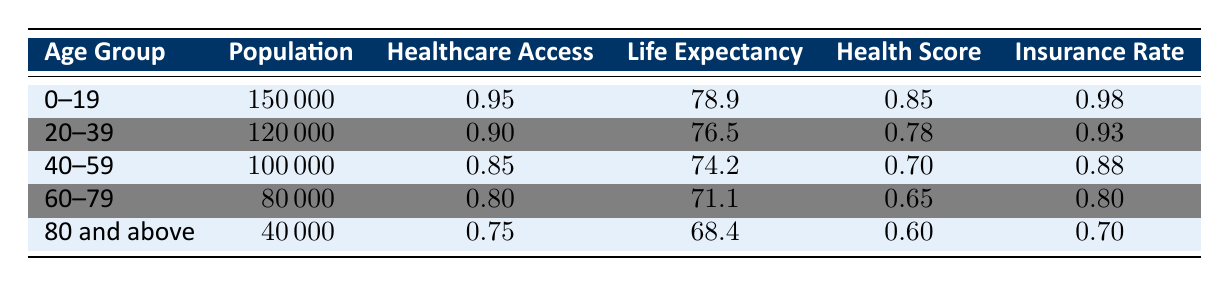What is the healthcare access rate for the age group 60-79? The healthcare access rate for the age group 60-79 can be directly found in the table under the "Healthcare Access" column for that age group. It shows 0.80.
Answer: 0.80 What is the average life expectancy for the age groups 40-59 and 60-79 combined? First, we find the life expectancy values for both age groups: 74.2 for 40-59 and 71.1 for 60-79. Next, we add these values: 74.2 + 71.1 = 145.3. Finally, we divide by 2 (the number of age groups) to get the average: 145.3 / 2 = 72.65.
Answer: 72.65 Is the insurance coverage rate for the age group 80 and above greater than the rate for the age group 60-79? We compare the insurance coverage rates for the two age groups from the table: for 80 and above, it's 0.70, and for 60-79, it's 0.80. Since 0.70 is not greater than 0.80, the statement is false.
Answer: No What is the total population of individuals aged 0-39? We need to add the populations of the age groups 0-19 and 20-39 together. The population for 0-19 is 150000, and for 20-39 it is 120000. Therefore, 150000 + 120000 = 270000.
Answer: 270000 Which age group has the lowest health outcomes score? By reviewing the "Health Score" column for all age groups, we find the scores: 0.85, 0.78, 0.70, 0.65, and 0.60. The lowest score is 0.60, which belongs to the age group 80 and above.
Answer: 80 and above How much lower is the healthcare access rate for the age group 40-59 compared to the age group 20-39? Looking at the healthcare access rates, we see they are 0.85 for 40-59 and 0.90 for 20-39. We subtract the two: 0.90 - 0.85 = 0.05, so the access rate for 40-59 is 0.05 lower.
Answer: 0.05 Does the average life expectancy decrease as age increases? We can observe the average life expectancy from the table for each age group: 78.9 for 0-19, 76.5 for 20-39, 74.2 for 40-59, 71.1 for 60-79, and 68.4 for 80 and above. Since these values are decreasing, the statement is true.
Answer: Yes What is the population difference between the age groups 20-39 and 60-79? The population for age group 20-39 is 120000, and for age group 60-79, it is 80000. We calculate the difference by subtracting: 120000 - 80000 = 40000.
Answer: 40000 What is the healthcare access rate for the age group with the highest population? The age group with the highest population is 0-19, with 150000 individuals. The healthcare access rate for this group is 0.95, which we find in the table.
Answer: 0.95 